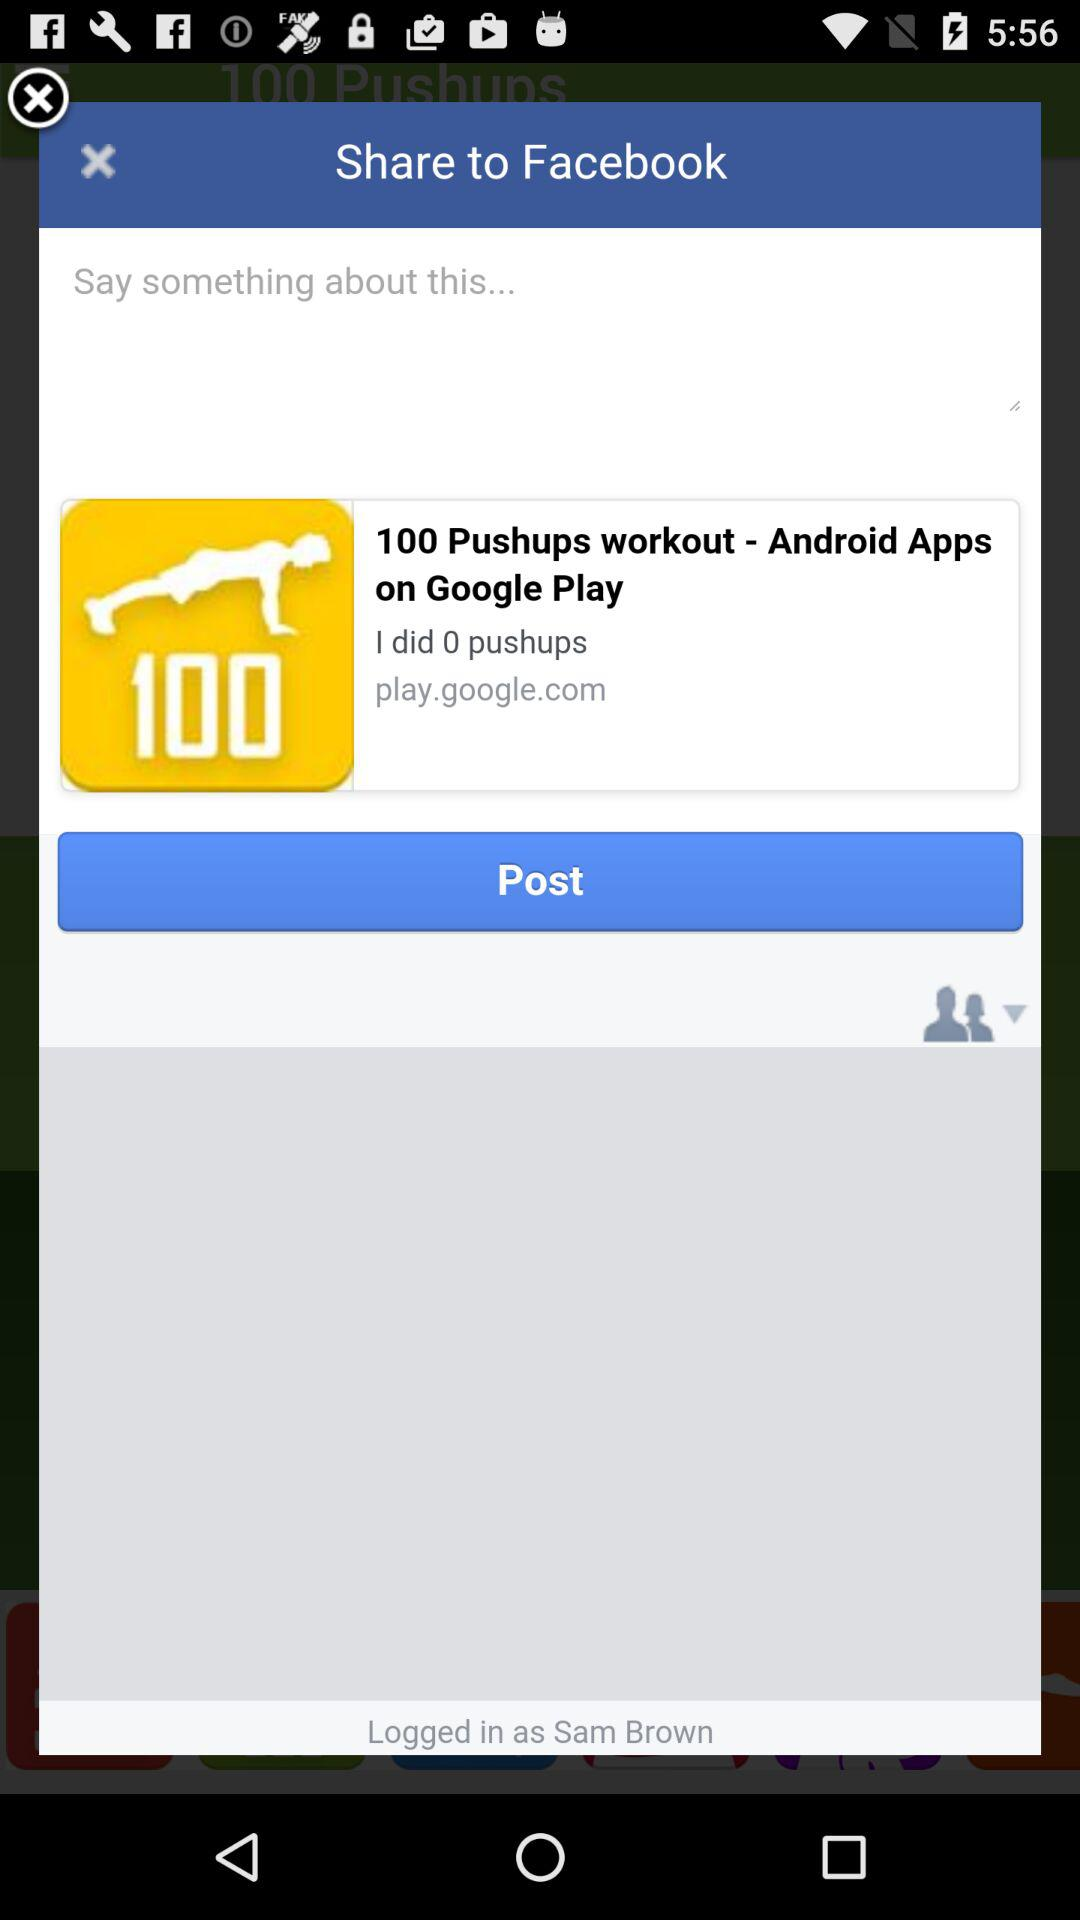What application can be used to share? The application that can be used to share is "Facebook". 